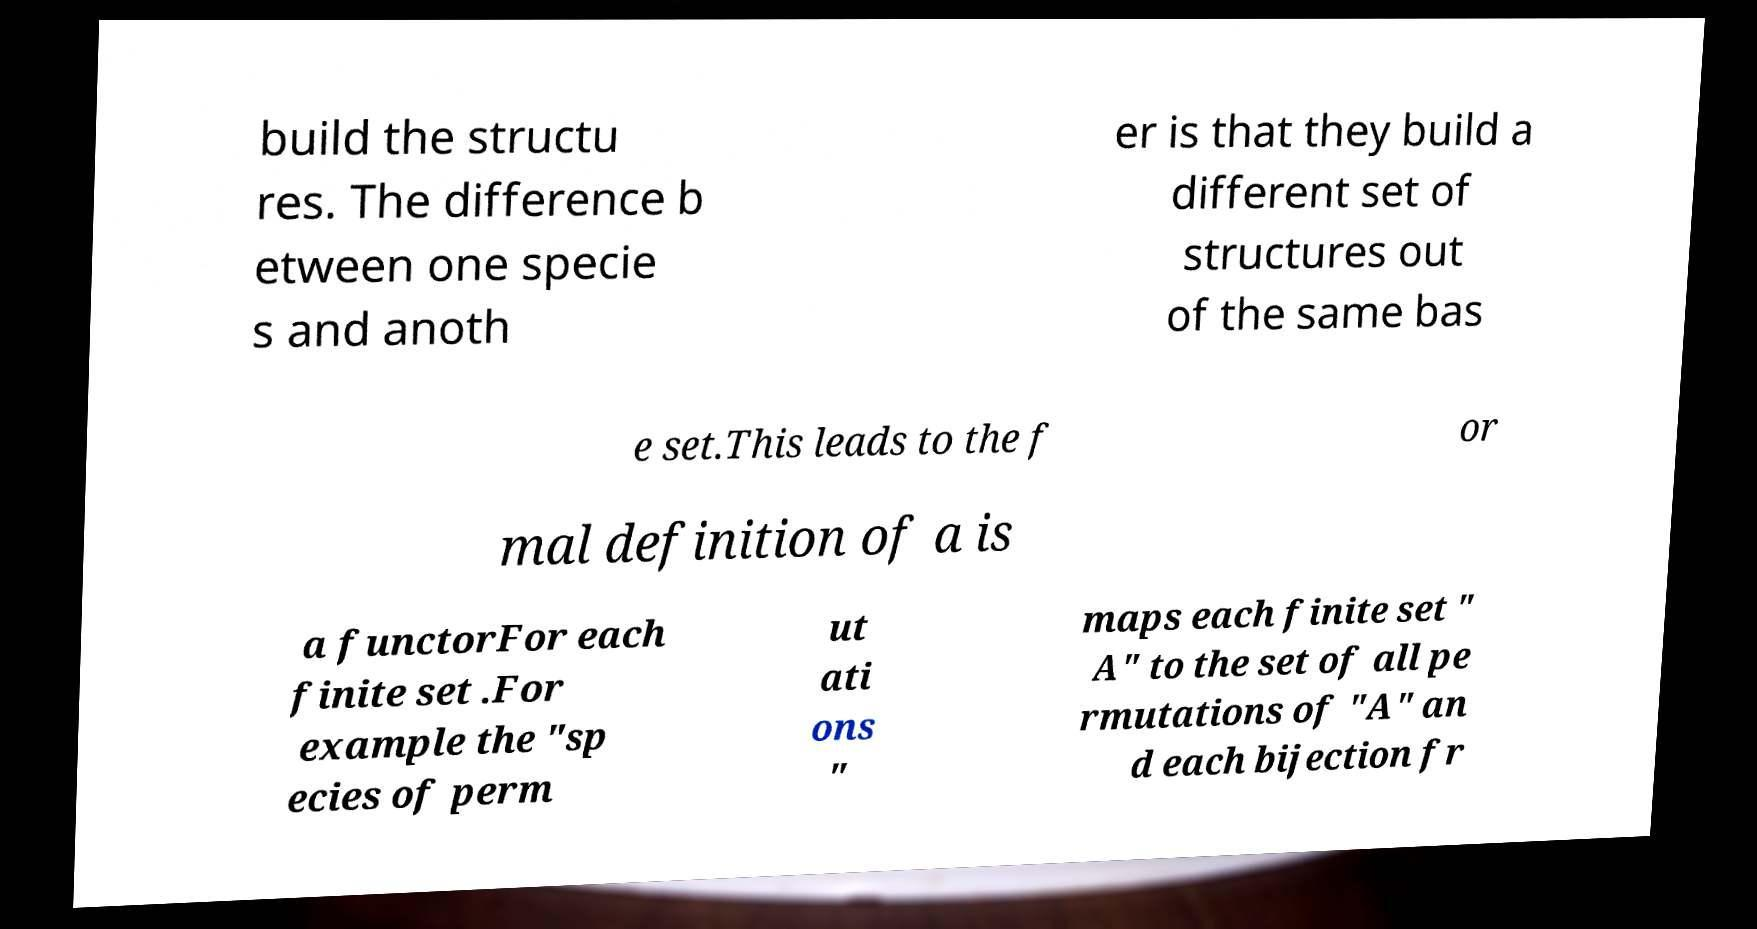Please read and relay the text visible in this image. What does it say? build the structu res. The difference b etween one specie s and anoth er is that they build a different set of structures out of the same bas e set.This leads to the f or mal definition of a is a functorFor each finite set .For example the "sp ecies of perm ut ati ons " maps each finite set " A" to the set of all pe rmutations of "A" an d each bijection fr 